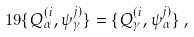Convert formula to latex. <formula><loc_0><loc_0><loc_500><loc_500>1 9 \{ Q ^ { ( i } _ { \alpha } , \psi ^ { j ) } _ { \gamma } \} = \{ Q ^ { ( i } _ { \gamma } , \psi ^ { j ) } _ { \alpha } \} \, ,</formula> 